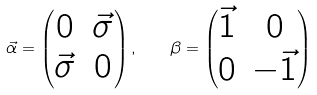Convert formula to latex. <formula><loc_0><loc_0><loc_500><loc_500>\vec { \alpha } = \begin{pmatrix} 0 & \vec { \sigma } \\ \vec { \sigma } & 0 \end{pmatrix} , \quad \beta = \begin{pmatrix} \vec { 1 } & 0 \\ 0 & - \vec { 1 } \end{pmatrix}</formula> 